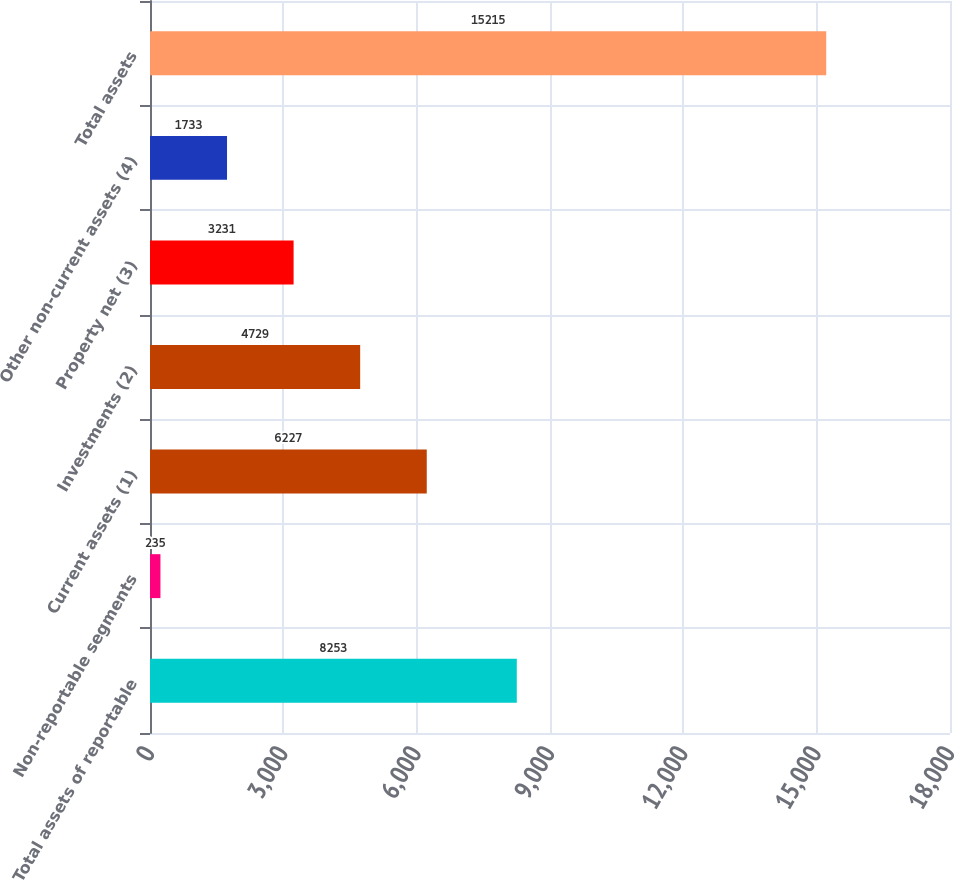Convert chart to OTSL. <chart><loc_0><loc_0><loc_500><loc_500><bar_chart><fcel>Total assets of reportable<fcel>Non-reportable segments<fcel>Current assets (1)<fcel>Investments (2)<fcel>Property net (3)<fcel>Other non-current assets (4)<fcel>Total assets<nl><fcel>8253<fcel>235<fcel>6227<fcel>4729<fcel>3231<fcel>1733<fcel>15215<nl></chart> 